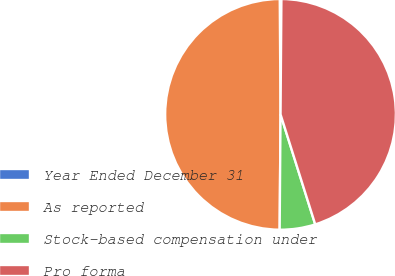Convert chart. <chart><loc_0><loc_0><loc_500><loc_500><pie_chart><fcel>Year Ended December 31<fcel>As reported<fcel>Stock-based compensation under<fcel>Pro forma<nl><fcel>0.23%<fcel>49.77%<fcel>4.98%<fcel>45.02%<nl></chart> 